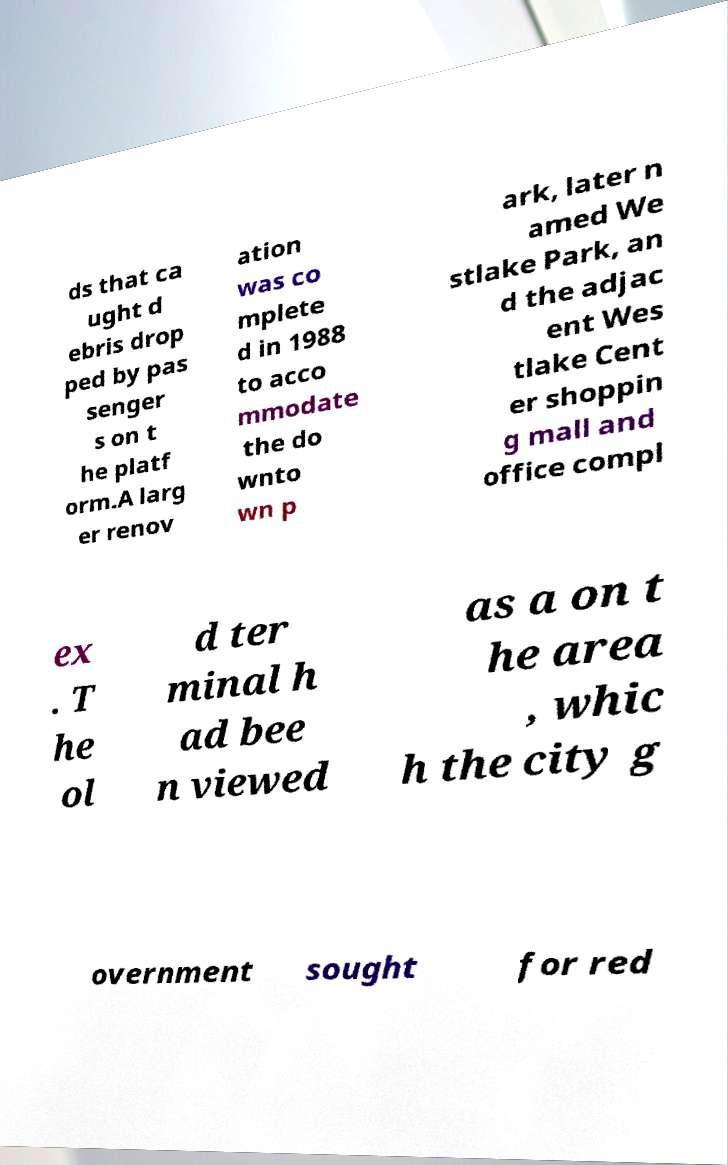Please identify and transcribe the text found in this image. ds that ca ught d ebris drop ped by pas senger s on t he platf orm.A larg er renov ation was co mplete d in 1988 to acco mmodate the do wnto wn p ark, later n amed We stlake Park, an d the adjac ent Wes tlake Cent er shoppin g mall and office compl ex . T he ol d ter minal h ad bee n viewed as a on t he area , whic h the city g overnment sought for red 